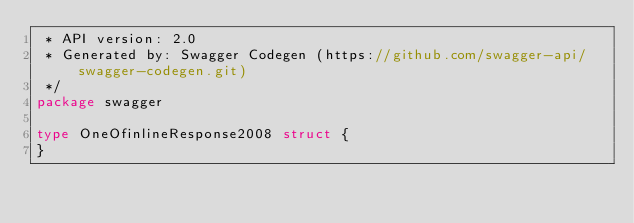Convert code to text. <code><loc_0><loc_0><loc_500><loc_500><_Go_> * API version: 2.0
 * Generated by: Swagger Codegen (https://github.com/swagger-api/swagger-codegen.git)
 */
package swagger

type OneOfinlineResponse2008 struct {
}
</code> 